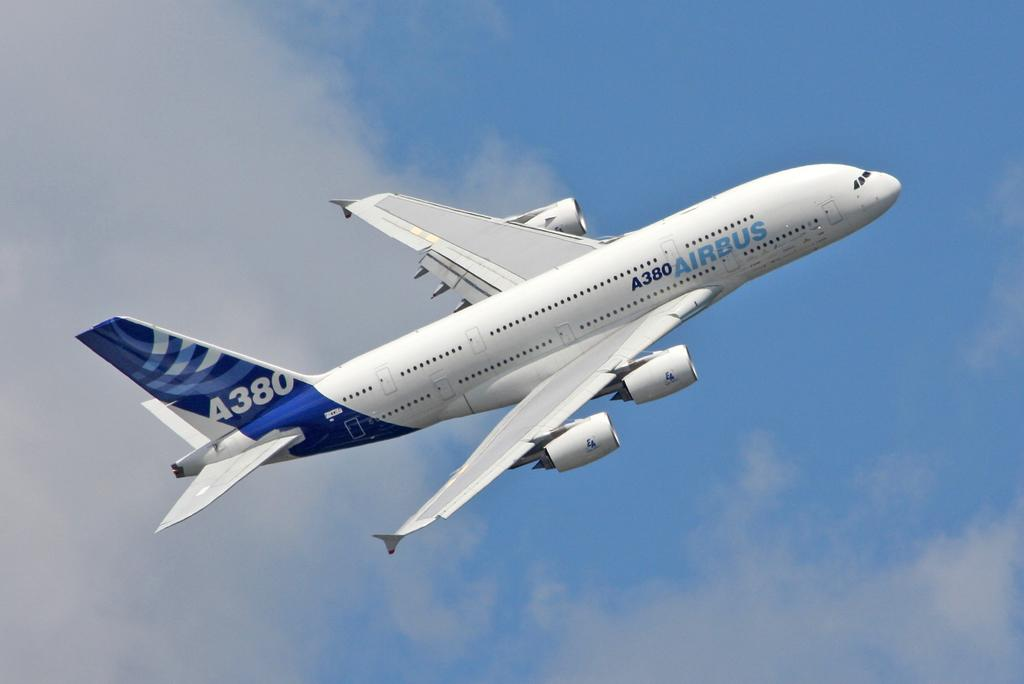<image>
Render a clear and concise summary of the photo. a plane that has A380 on the plane 